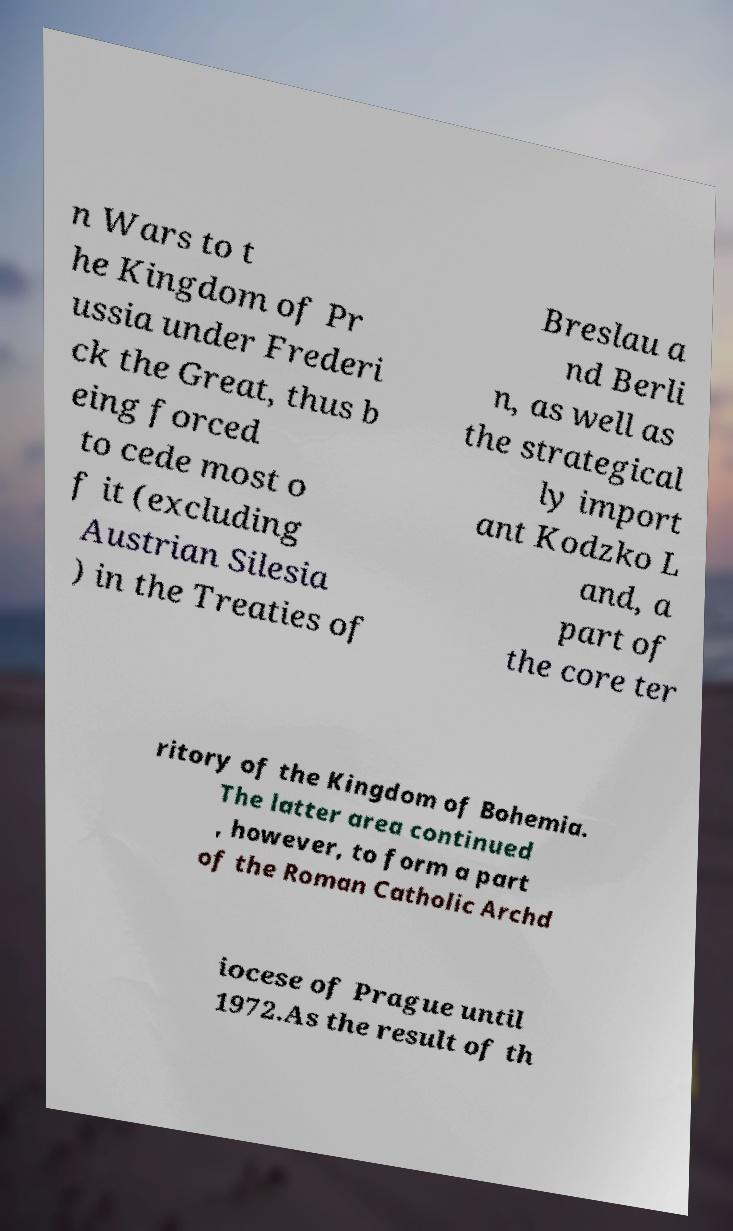Please read and relay the text visible in this image. What does it say? n Wars to t he Kingdom of Pr ussia under Frederi ck the Great, thus b eing forced to cede most o f it (excluding Austrian Silesia ) in the Treaties of Breslau a nd Berli n, as well as the strategical ly import ant Kodzko L and, a part of the core ter ritory of the Kingdom of Bohemia. The latter area continued , however, to form a part of the Roman Catholic Archd iocese of Prague until 1972.As the result of th 